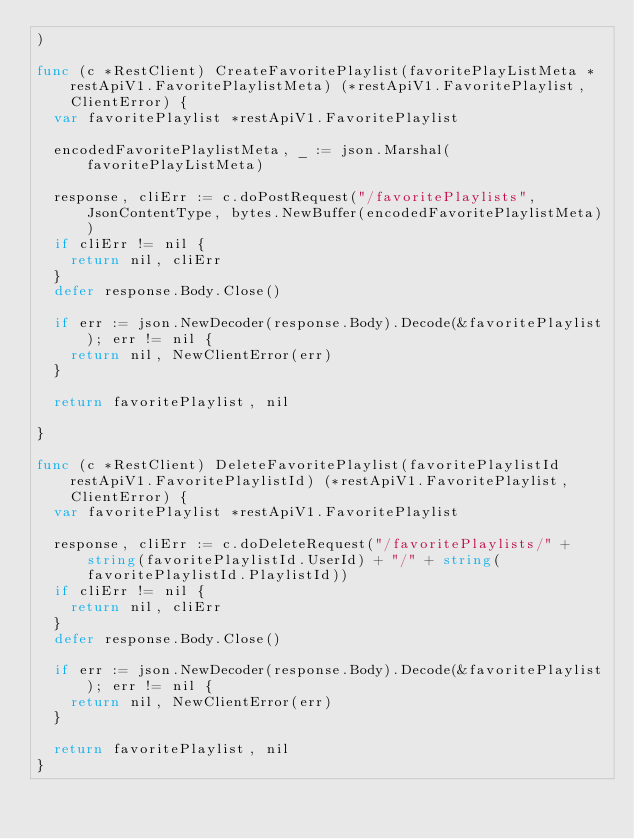<code> <loc_0><loc_0><loc_500><loc_500><_Go_>)

func (c *RestClient) CreateFavoritePlaylist(favoritePlayListMeta *restApiV1.FavoritePlaylistMeta) (*restApiV1.FavoritePlaylist, ClientError) {
	var favoritePlaylist *restApiV1.FavoritePlaylist

	encodedFavoritePlaylistMeta, _ := json.Marshal(favoritePlayListMeta)

	response, cliErr := c.doPostRequest("/favoritePlaylists", JsonContentType, bytes.NewBuffer(encodedFavoritePlaylistMeta))
	if cliErr != nil {
		return nil, cliErr
	}
	defer response.Body.Close()

	if err := json.NewDecoder(response.Body).Decode(&favoritePlaylist); err != nil {
		return nil, NewClientError(err)
	}

	return favoritePlaylist, nil

}

func (c *RestClient) DeleteFavoritePlaylist(favoritePlaylistId restApiV1.FavoritePlaylistId) (*restApiV1.FavoritePlaylist, ClientError) {
	var favoritePlaylist *restApiV1.FavoritePlaylist

	response, cliErr := c.doDeleteRequest("/favoritePlaylists/" + string(favoritePlaylistId.UserId) + "/" + string(favoritePlaylistId.PlaylistId))
	if cliErr != nil {
		return nil, cliErr
	}
	defer response.Body.Close()

	if err := json.NewDecoder(response.Body).Decode(&favoritePlaylist); err != nil {
		return nil, NewClientError(err)
	}

	return favoritePlaylist, nil
}
</code> 